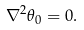<formula> <loc_0><loc_0><loc_500><loc_500>\nabla ^ { 2 } \theta _ { 0 } = 0 .</formula> 